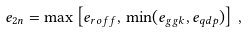Convert formula to latex. <formula><loc_0><loc_0><loc_500><loc_500>e _ { 2 n } = \max \left [ e _ { r o f f } , \, \min ( e _ { g g k } , e _ { q d p } ) \right ] \, ,</formula> 